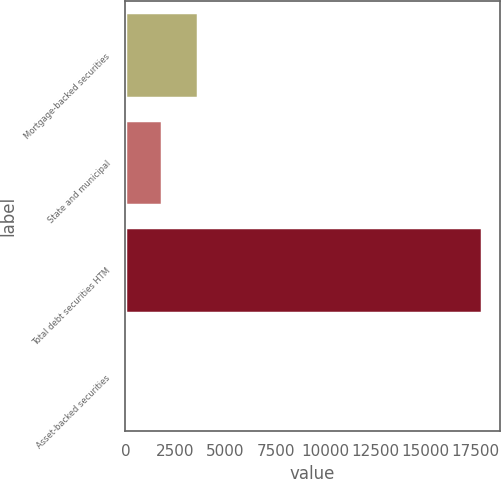<chart> <loc_0><loc_0><loc_500><loc_500><bar_chart><fcel>Mortgage-backed securities<fcel>State and municipal<fcel>Total debt securities HTM<fcel>Asset-backed securities<nl><fcel>3619.6<fcel>1845.3<fcel>17814<fcel>71<nl></chart> 